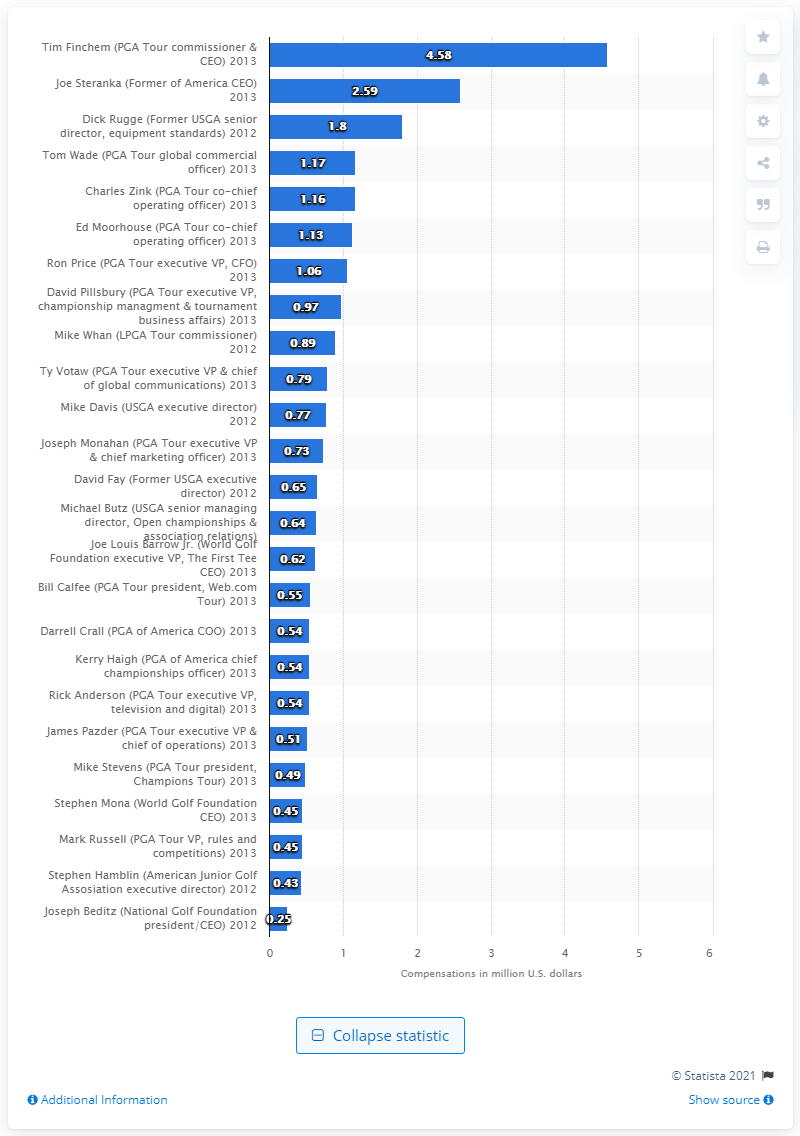Identify some key points in this picture. Tim Finchem earns a salary of 4.58... 